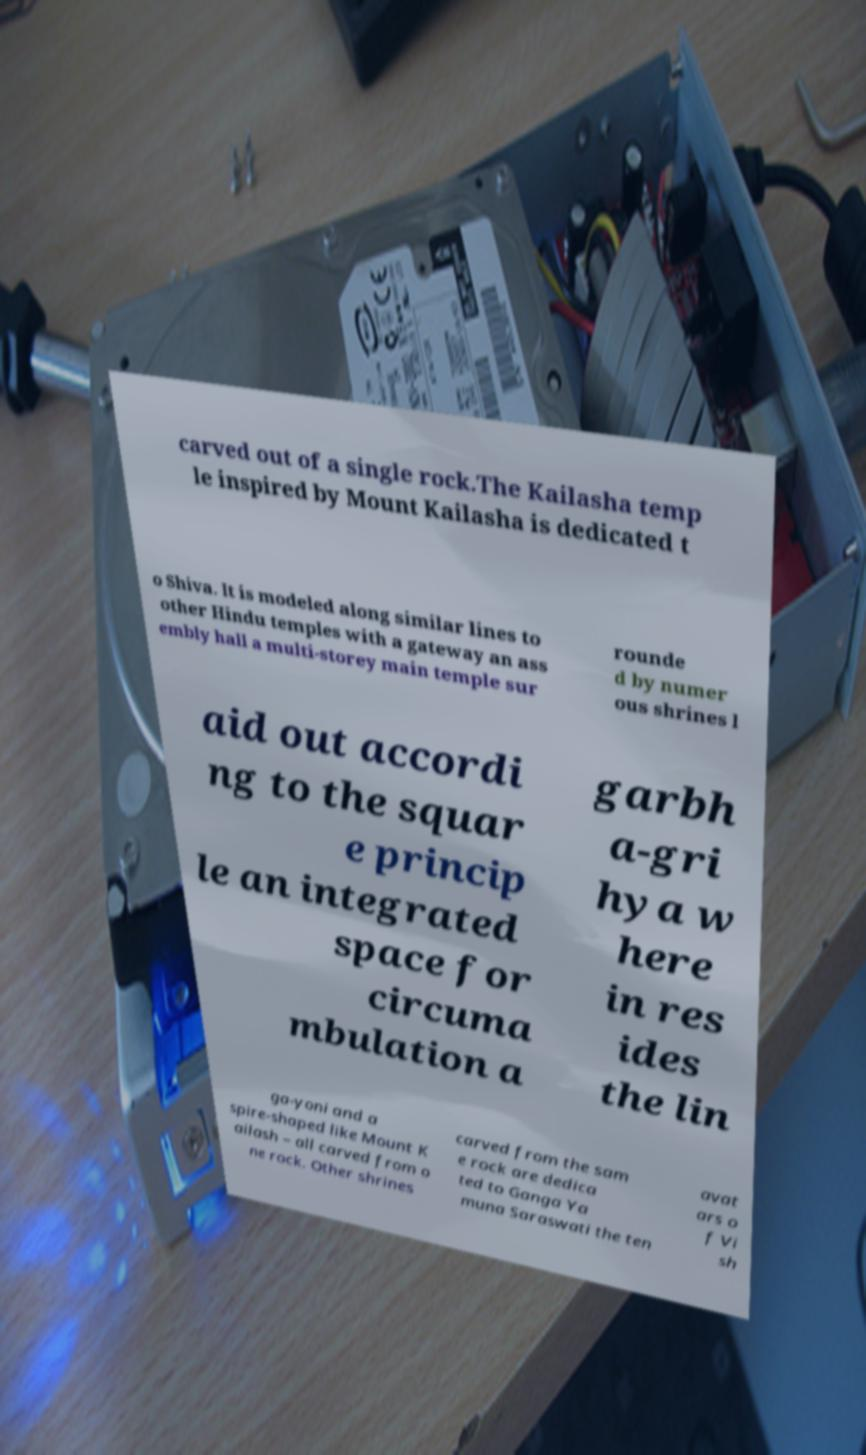Can you read and provide the text displayed in the image?This photo seems to have some interesting text. Can you extract and type it out for me? carved out of a single rock.The Kailasha temp le inspired by Mount Kailasha is dedicated t o Shiva. It is modeled along similar lines to other Hindu temples with a gateway an ass embly hall a multi-storey main temple sur rounde d by numer ous shrines l aid out accordi ng to the squar e princip le an integrated space for circuma mbulation a garbh a-gri hya w here in res ides the lin ga-yoni and a spire-shaped like Mount K ailash – all carved from o ne rock. Other shrines carved from the sam e rock are dedica ted to Ganga Ya muna Saraswati the ten avat ars o f Vi sh 